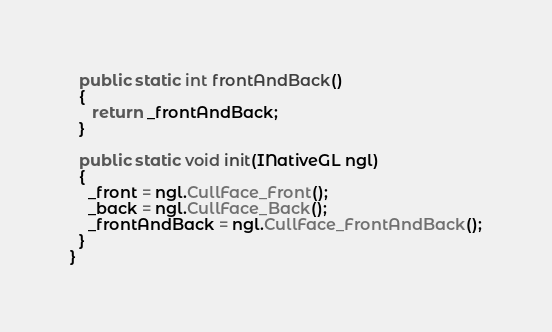<code> <loc_0><loc_0><loc_500><loc_500><_Java_>  public static int frontAndBack()
  {
     return _frontAndBack;
  }

  public static void init(INativeGL ngl)
  {
    _front = ngl.CullFace_Front();
    _back = ngl.CullFace_Back();
    _frontAndBack = ngl.CullFace_FrontAndBack();
  }
}
</code> 